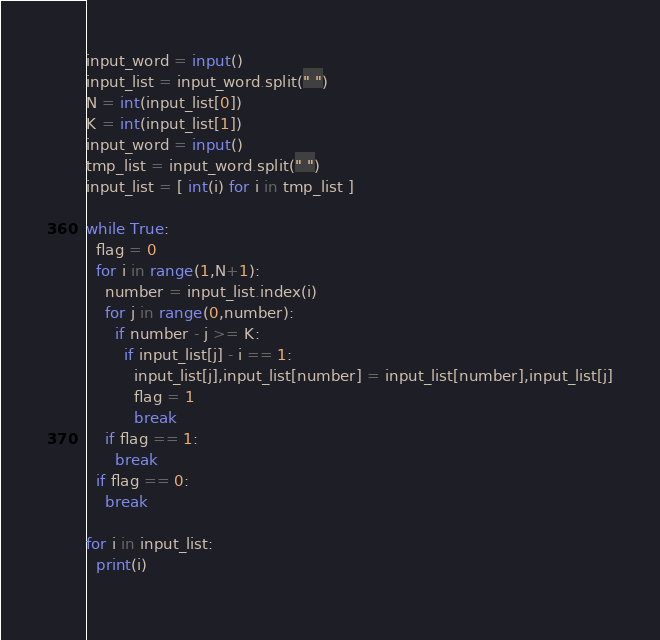<code> <loc_0><loc_0><loc_500><loc_500><_Python_>input_word = input()
input_list = input_word.split(" ")
N = int(input_list[0])
K = int(input_list[1])
input_word = input()
tmp_list = input_word.split(" ")
input_list = [ int(i) for i in tmp_list ]

while True:
  flag = 0
  for i in range(1,N+1):
    number = input_list.index(i)
    for j in range(0,number):
      if number - j >= K:
        if input_list[j] - i == 1:
          input_list[j],input_list[number] = input_list[number],input_list[j]
          flag = 1
          break
    if flag == 1:
      break
  if flag == 0:
    break

for i in input_list:
  print(i)
      </code> 